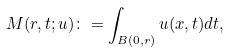Convert formula to latex. <formula><loc_0><loc_0><loc_500><loc_500>M ( r , t ; u ) \colon = \int _ { B ( 0 , r ) } u ( x , t ) d t ,</formula> 